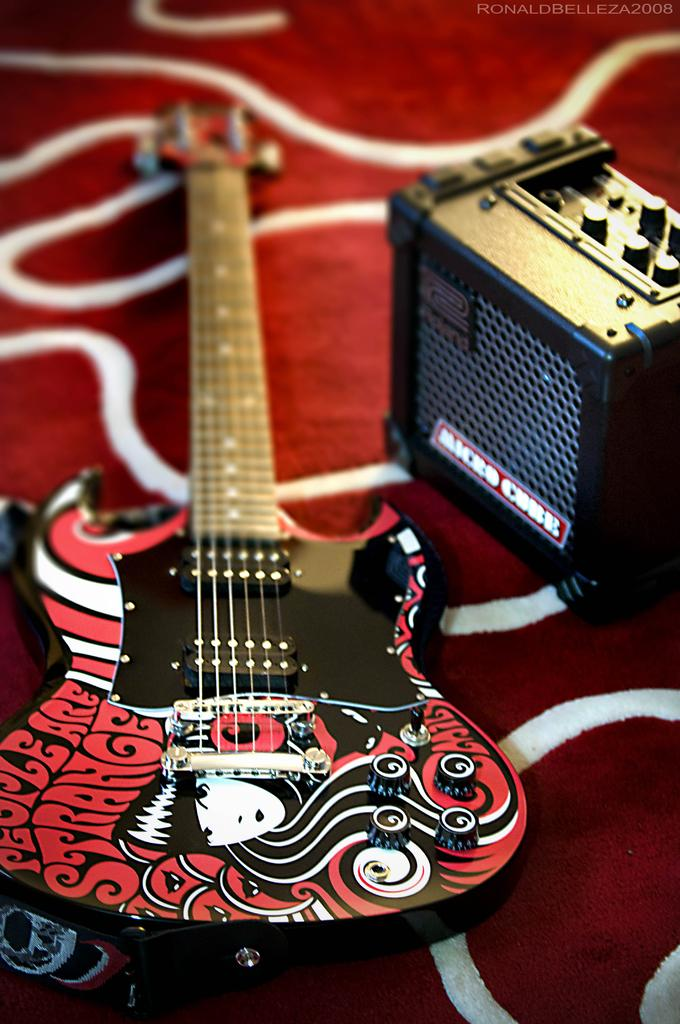What musical instrument can be seen in the image? There is a guitar in the image. What type of surface are the objects placed on in the image? The objects are placed on a carpet in the image. How many cars are parked on the carpet in the image? There are no cars present in the image; it features a guitar and objects placed on a carpet. What is the reason for the guitar being placed on the carpet in the image? The provided facts do not give any information about the reason for the guitar being placed on the carpet, so we cannot determine the reason from the image. 